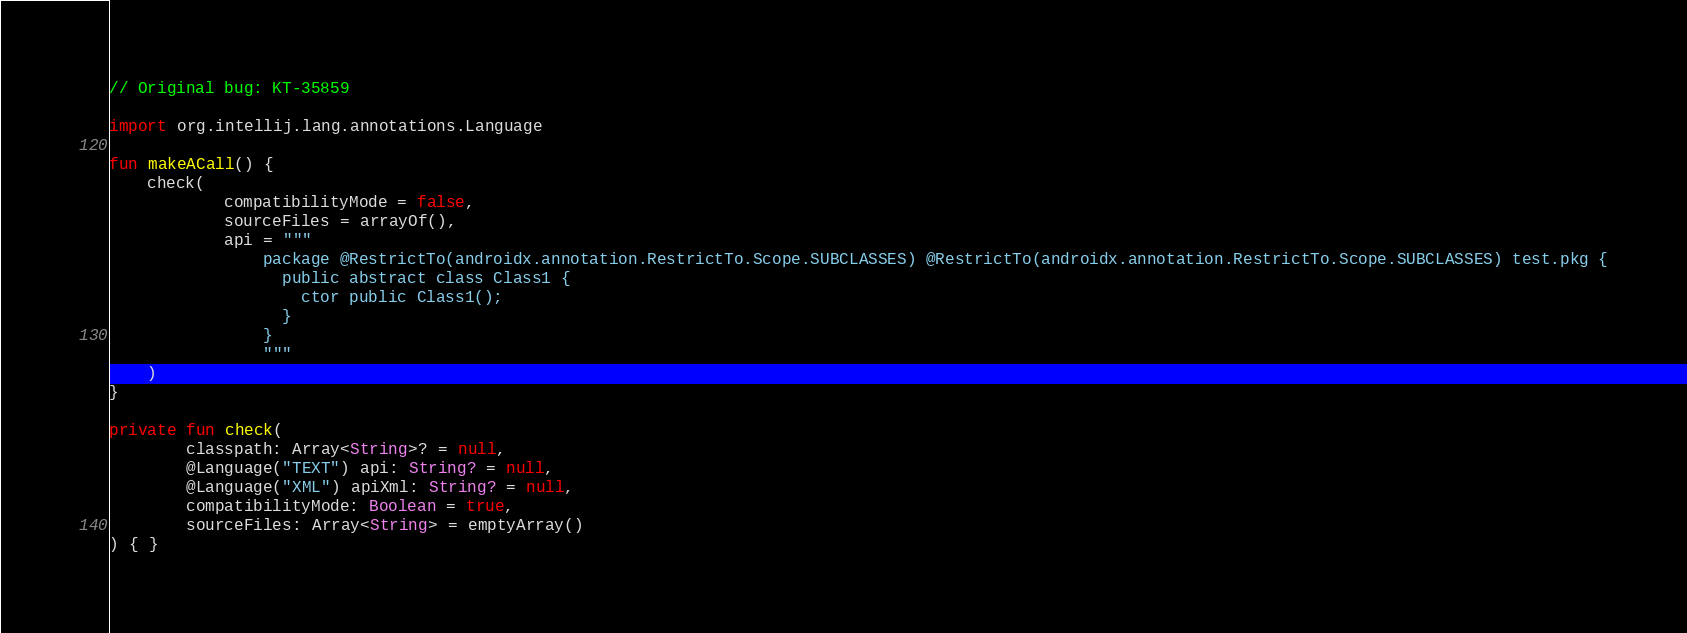<code> <loc_0><loc_0><loc_500><loc_500><_Kotlin_>// Original bug: KT-35859

import org.intellij.lang.annotations.Language

fun makeACall() {
    check(
            compatibilityMode = false,
            sourceFiles = arrayOf(),
            api = """
                package @RestrictTo(androidx.annotation.RestrictTo.Scope.SUBCLASSES) @RestrictTo(androidx.annotation.RestrictTo.Scope.SUBCLASSES) test.pkg {
                  public abstract class Class1 {
                    ctor public Class1();
                  }
                }
                """
    )
}

private fun check(
        classpath: Array<String>? = null,
        @Language("TEXT") api: String? = null,
        @Language("XML") apiXml: String? = null,
        compatibilityMode: Boolean = true,
        sourceFiles: Array<String> = emptyArray()
) { }

</code> 